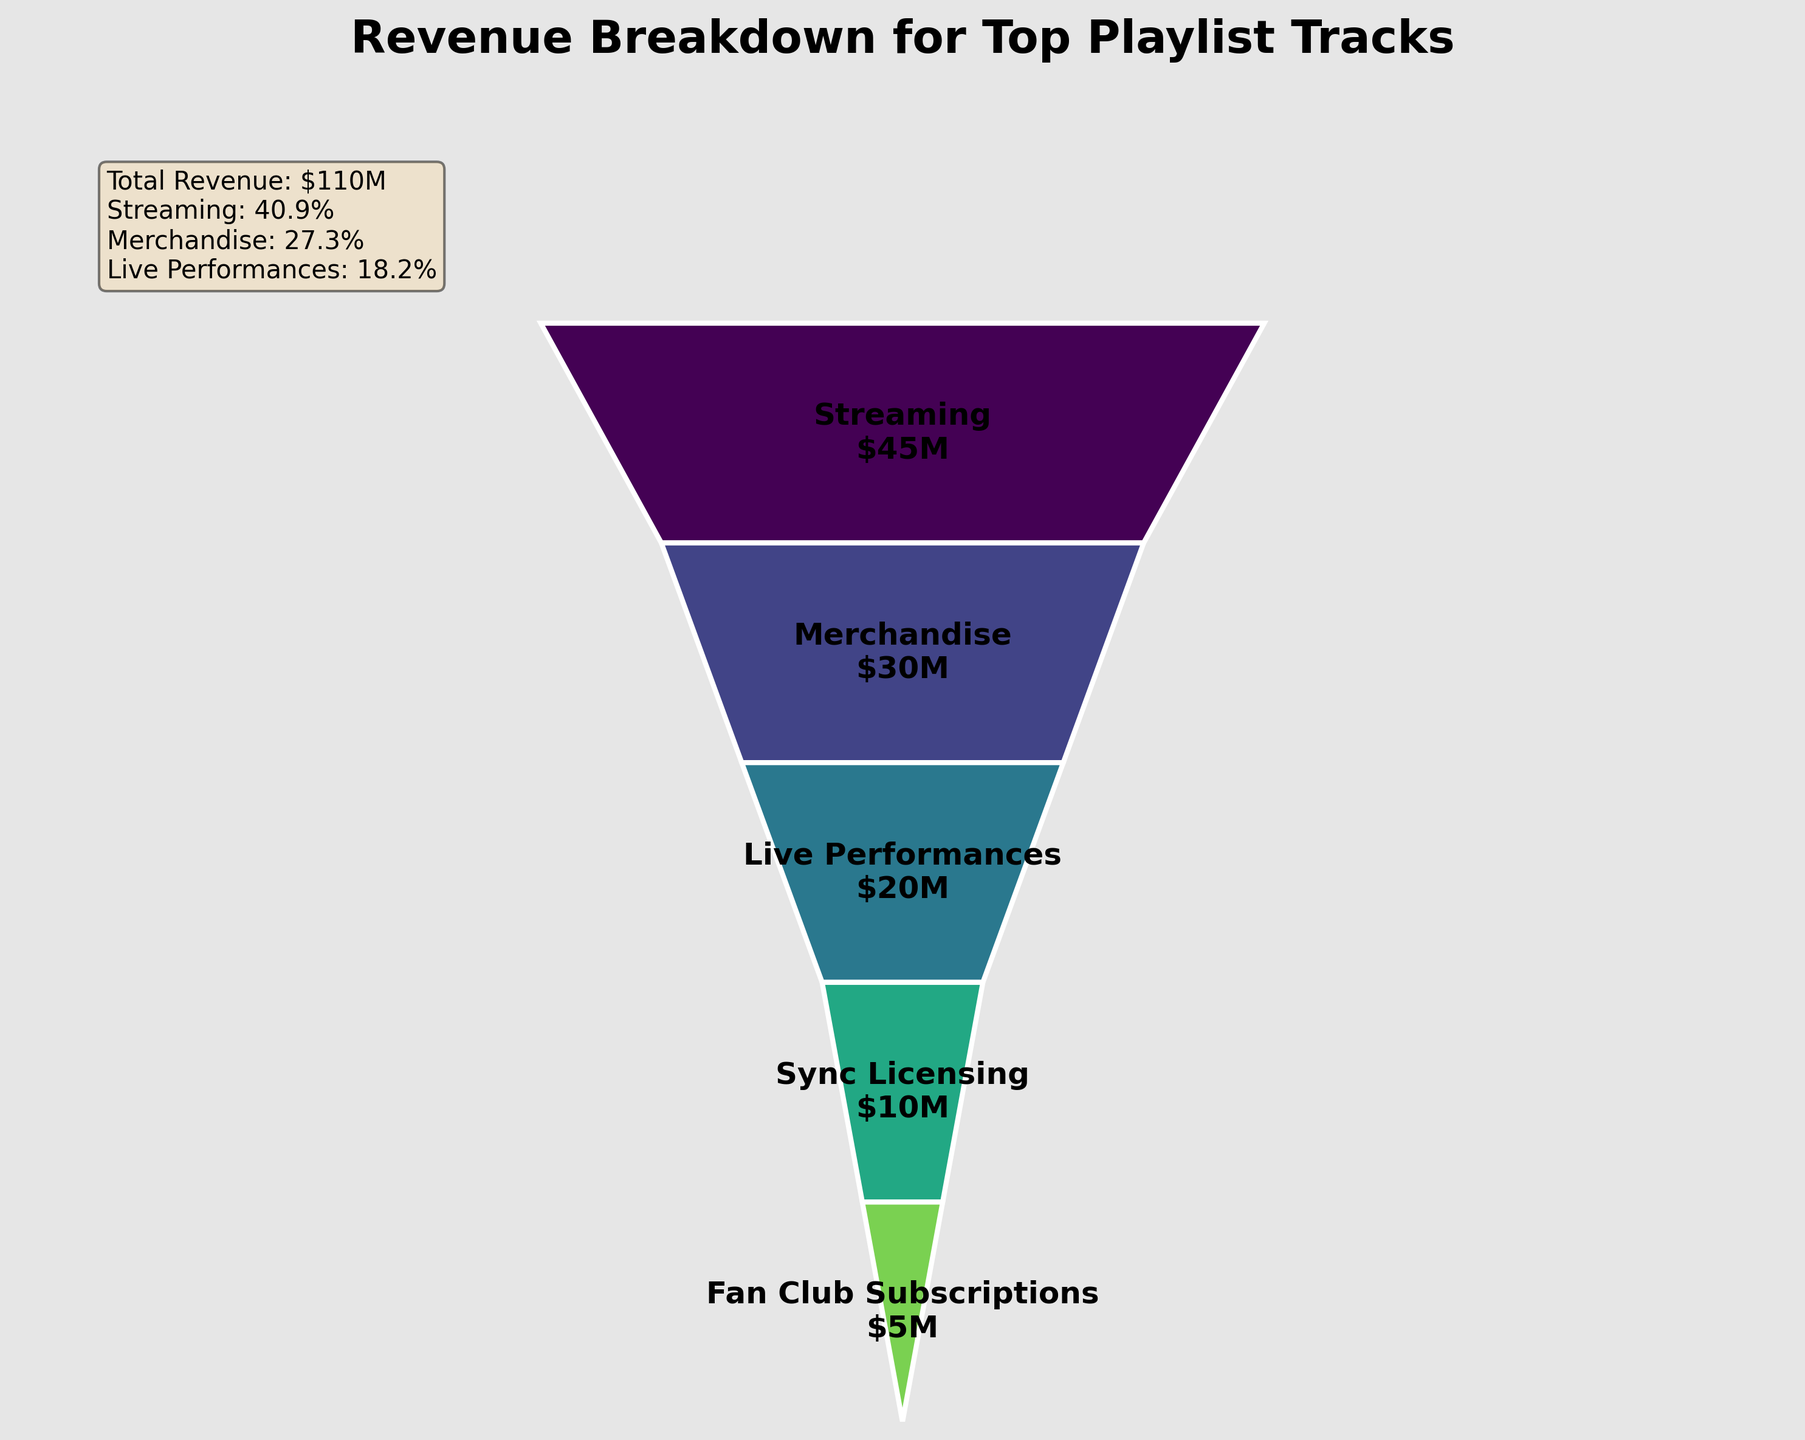What is the title of the chart? The title is usually placed at the top of the chart and is clearly readable.
Answer: Revenue Breakdown for Top Playlist Tracks Which revenue stream contributes the most to the total revenue? The segment with the largest size and value represents the highest contribution. According to the figure, Streaming has the highest value.
Answer: Streaming What percentage of the total revenue is generated from merchandise? To find the percentage, divide the Merchandise revenue by the total revenue and multiply by 100: (30/110) * 100 = 27.27%. From the legend-like text box, the percentage is rounded.
Answer: 27.3% How much more revenue is generated from live performances compared to fan club subscriptions? Subtract the revenue from Fan Club Subscriptions from Live Performances: 20 - 5 = 15.
Answer: $15M Arrange the revenue streams in descending order of their contribution. Examine the segments and their labeled values to order them from largest to smallest: Streaming, Merchandise, Live Performances, Sync Licensing, Fan Club Subscriptions.
Answer: Streaming, Merchandise, Live Performances, Sync Licensing, Fan Club Subscriptions What is the combined revenue from merchandise and live performances? Add the values for Merchandise and Live Performances: 30 + 20 = 50.
Answer: $50M By how much does the revenue from merchandise exceed the revenue from sync licensing? Subtract Sync Licensing revenue from Merchandise revenue: 30 - 10 = 20.
Answer: $20M Which are the two least contributing revenue streams? The segments with the smallest sizes are the least contributing: Sync Licensing and Fan Club Subscriptions.
Answer: Sync Licensing and Fan Club Subscriptions What is the approximate total revenue, as displayed in the text box? The text box specifically mentions the combined amount, which is easy to read off from the figure.
Answer: $110M 